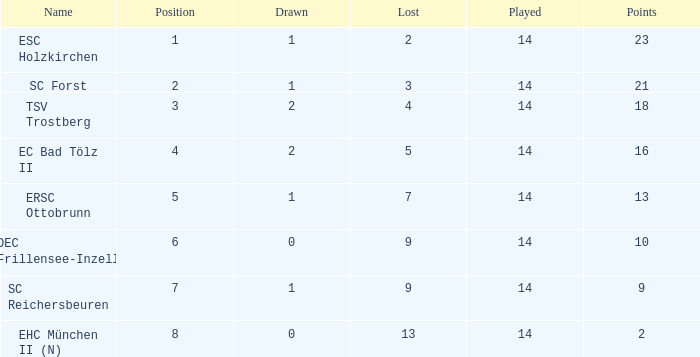Parse the full table. {'header': ['Name', 'Position', 'Drawn', 'Lost', 'Played', 'Points'], 'rows': [['ESC Holzkirchen', '1', '1', '2', '14', '23'], ['SC Forst', '2', '1', '3', '14', '21'], ['TSV Trostberg', '3', '2', '4', '14', '18'], ['EC Bad Tölz II', '4', '2', '5', '14', '16'], ['ERSC Ottobrunn', '5', '1', '7', '14', '13'], ['DEC Frillensee-Inzell', '6', '0', '9', '14', '10'], ['SC Reichersbeuren', '7', '1', '9', '14', '9'], ['EHC München II (N)', '8', '0', '13', '14', '2']]} Which Points have a Position larger than 6, and a Lost smaller than 13? 9.0. 